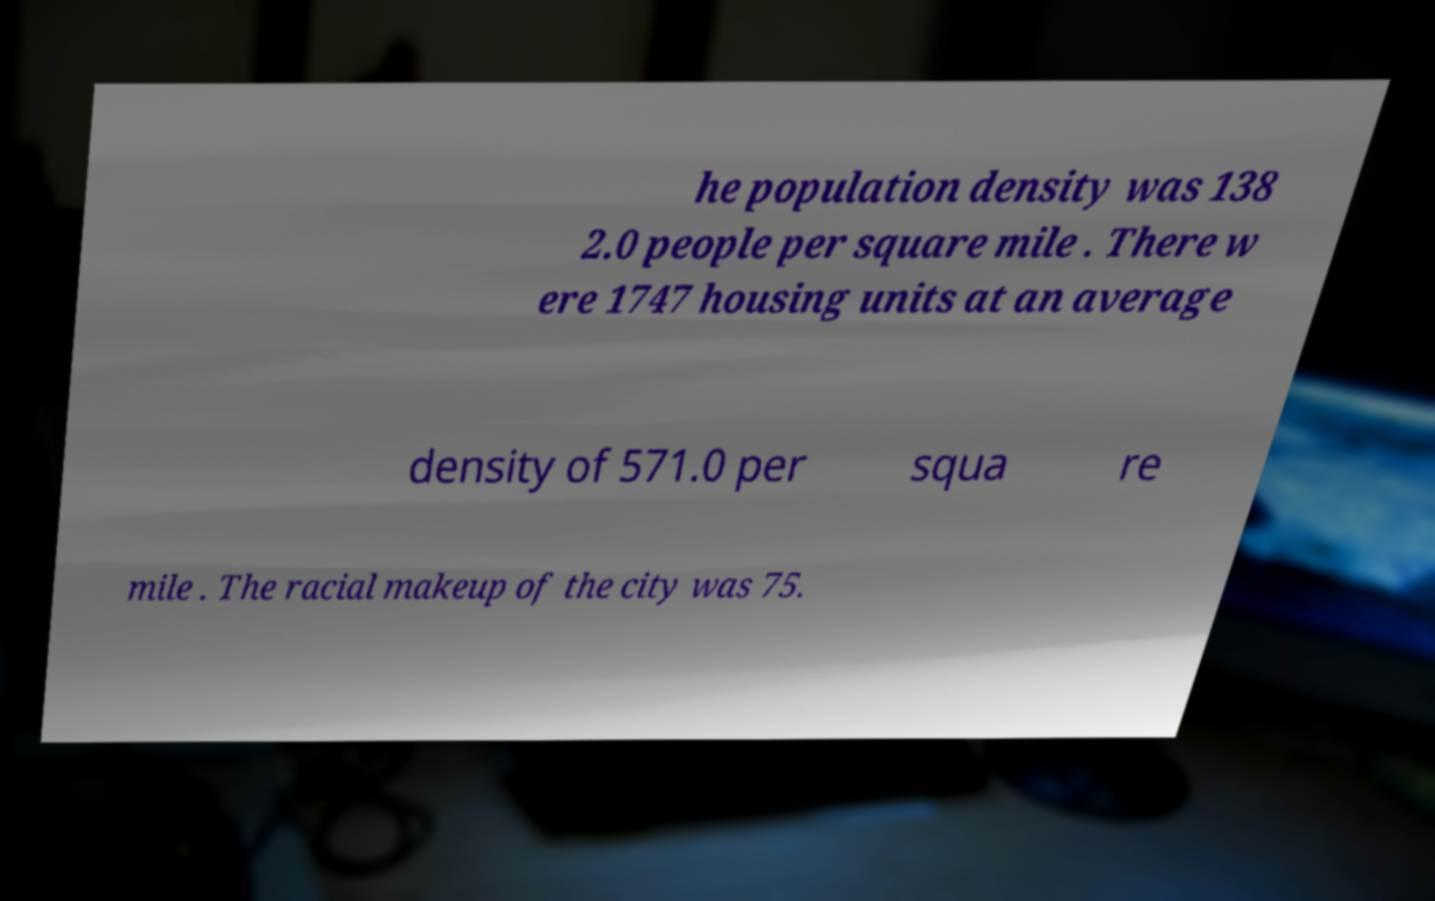Can you read and provide the text displayed in the image?This photo seems to have some interesting text. Can you extract and type it out for me? he population density was 138 2.0 people per square mile . There w ere 1747 housing units at an average density of 571.0 per squa re mile . The racial makeup of the city was 75. 